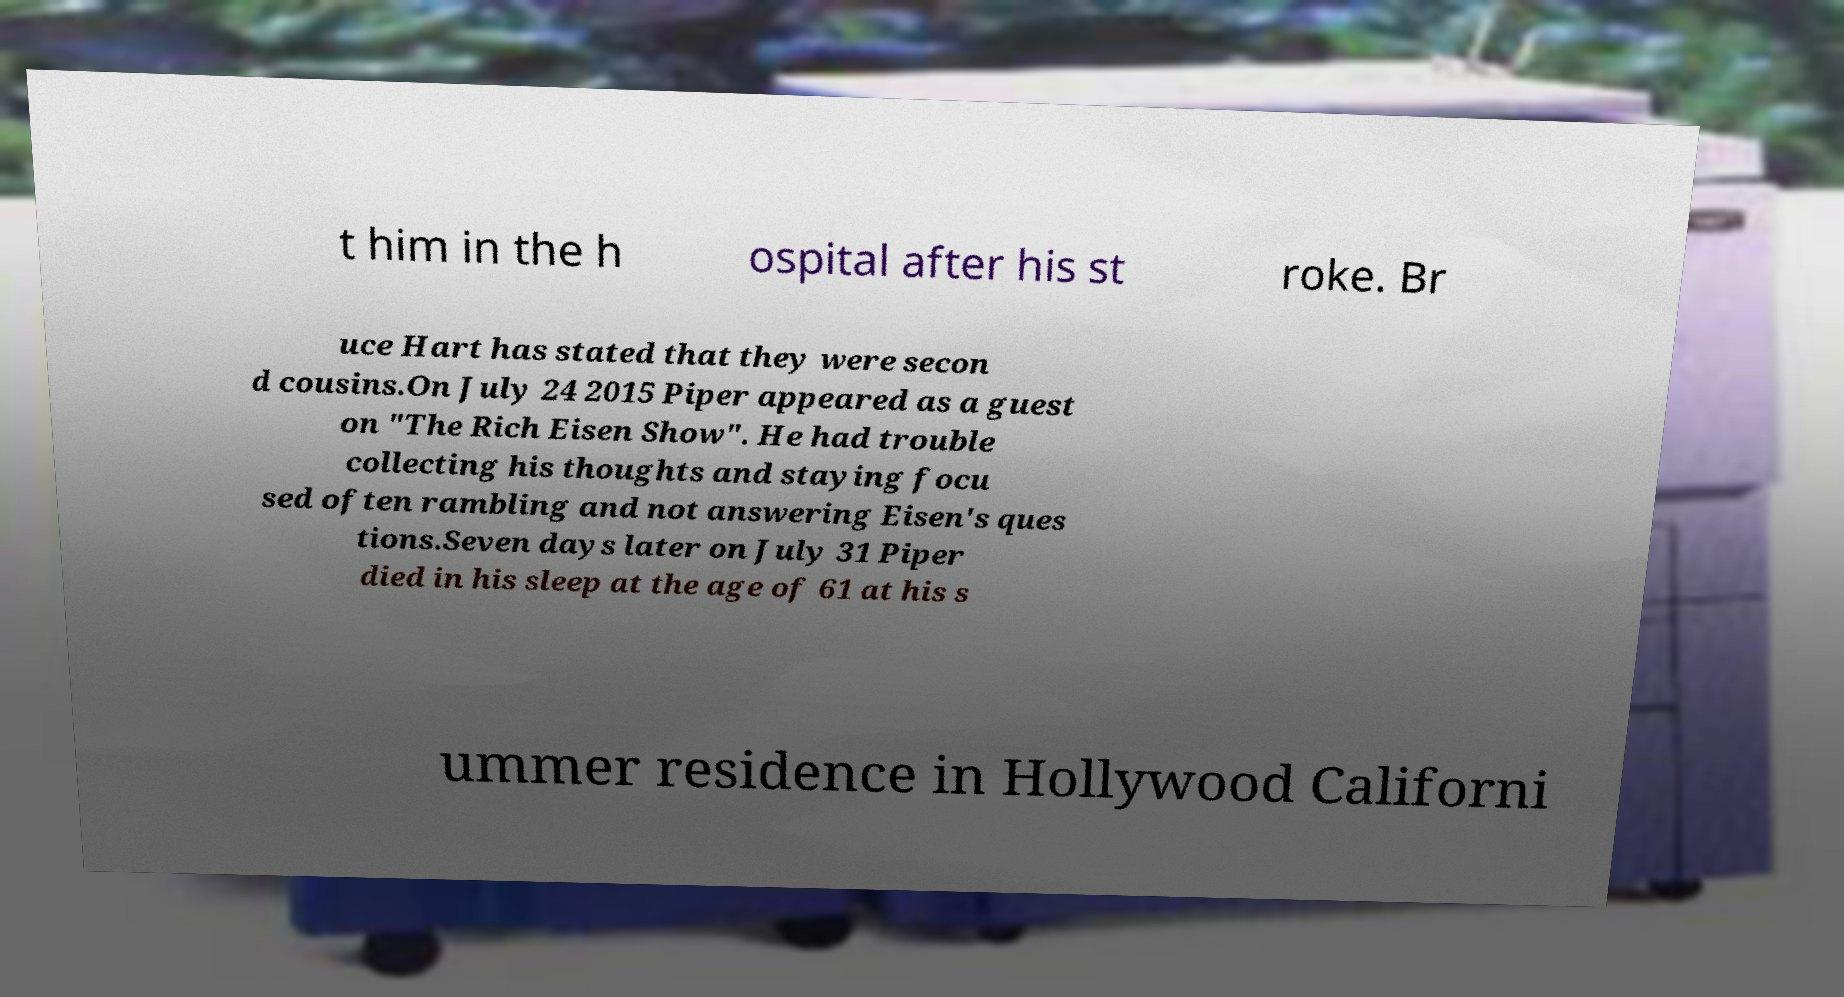Please identify and transcribe the text found in this image. t him in the h ospital after his st roke. Br uce Hart has stated that they were secon d cousins.On July 24 2015 Piper appeared as a guest on "The Rich Eisen Show". He had trouble collecting his thoughts and staying focu sed often rambling and not answering Eisen's ques tions.Seven days later on July 31 Piper died in his sleep at the age of 61 at his s ummer residence in Hollywood Californi 